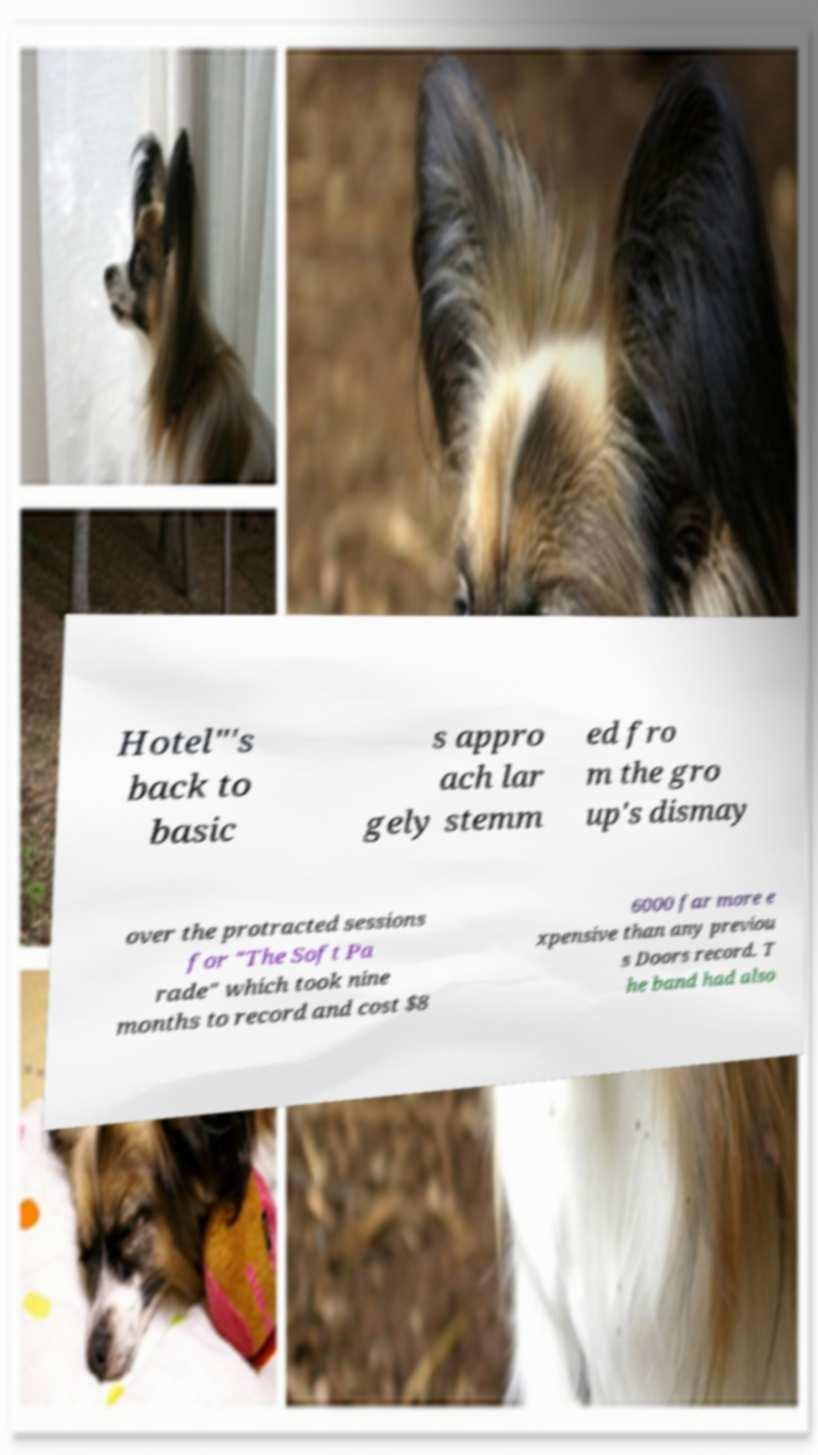Could you extract and type out the text from this image? Hotel"'s back to basic s appro ach lar gely stemm ed fro m the gro up's dismay over the protracted sessions for "The Soft Pa rade" which took nine months to record and cost $8 6000 far more e xpensive than any previou s Doors record. T he band had also 